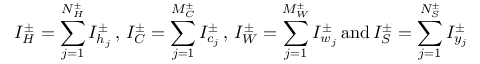<formula> <loc_0><loc_0><loc_500><loc_500>I _ { H } ^ { \pm } = \sum _ { j = 1 } ^ { N _ { H } ^ { \pm } } I _ { h _ { j } } ^ { \pm } \, , \, I _ { C } ^ { \pm } = \sum _ { j = 1 } ^ { M _ { C } ^ { \pm } } I _ { c _ { j } } ^ { \pm } \, , \, I _ { W } ^ { \pm } = \sum _ { j = 1 } ^ { M _ { W } ^ { \pm } } I _ { w _ { j } } ^ { \pm } \, a n d \, I _ { S } ^ { \pm } = \sum _ { j = 1 } ^ { N _ { S } ^ { \pm } } I _ { y _ { j } } ^ { \pm }</formula> 